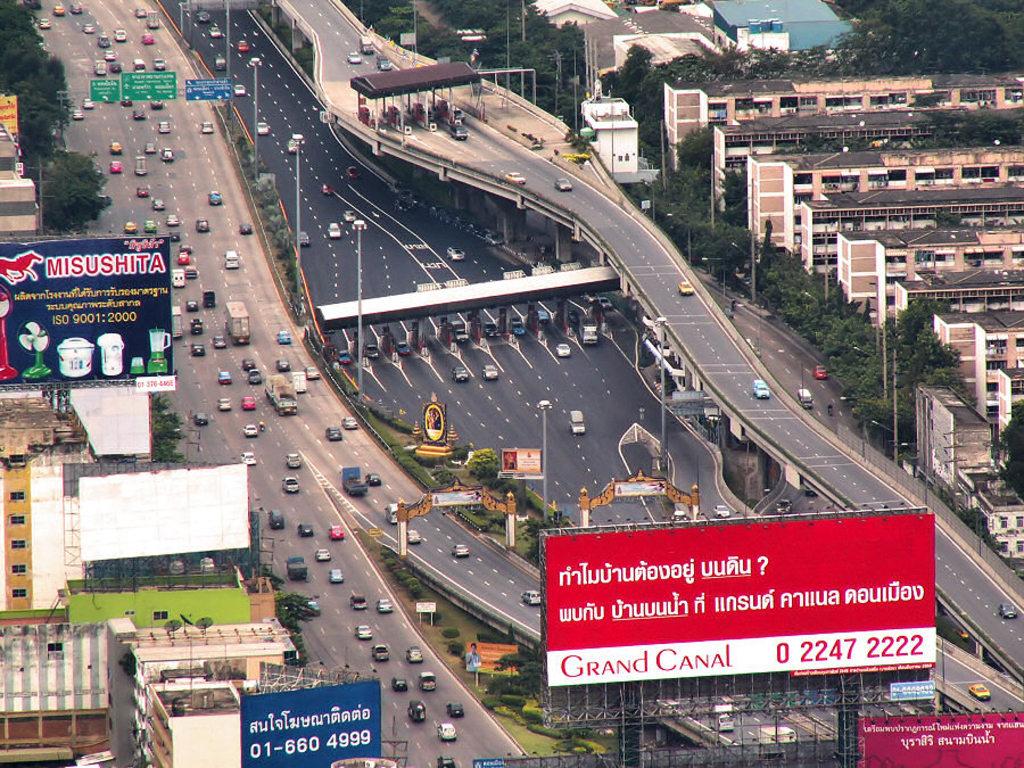If i wanted to reach the grand canal what number would i dial?
Offer a terse response. 022472222. What's the phone number for on the blue sign?
Offer a terse response. 01-660 4999. 